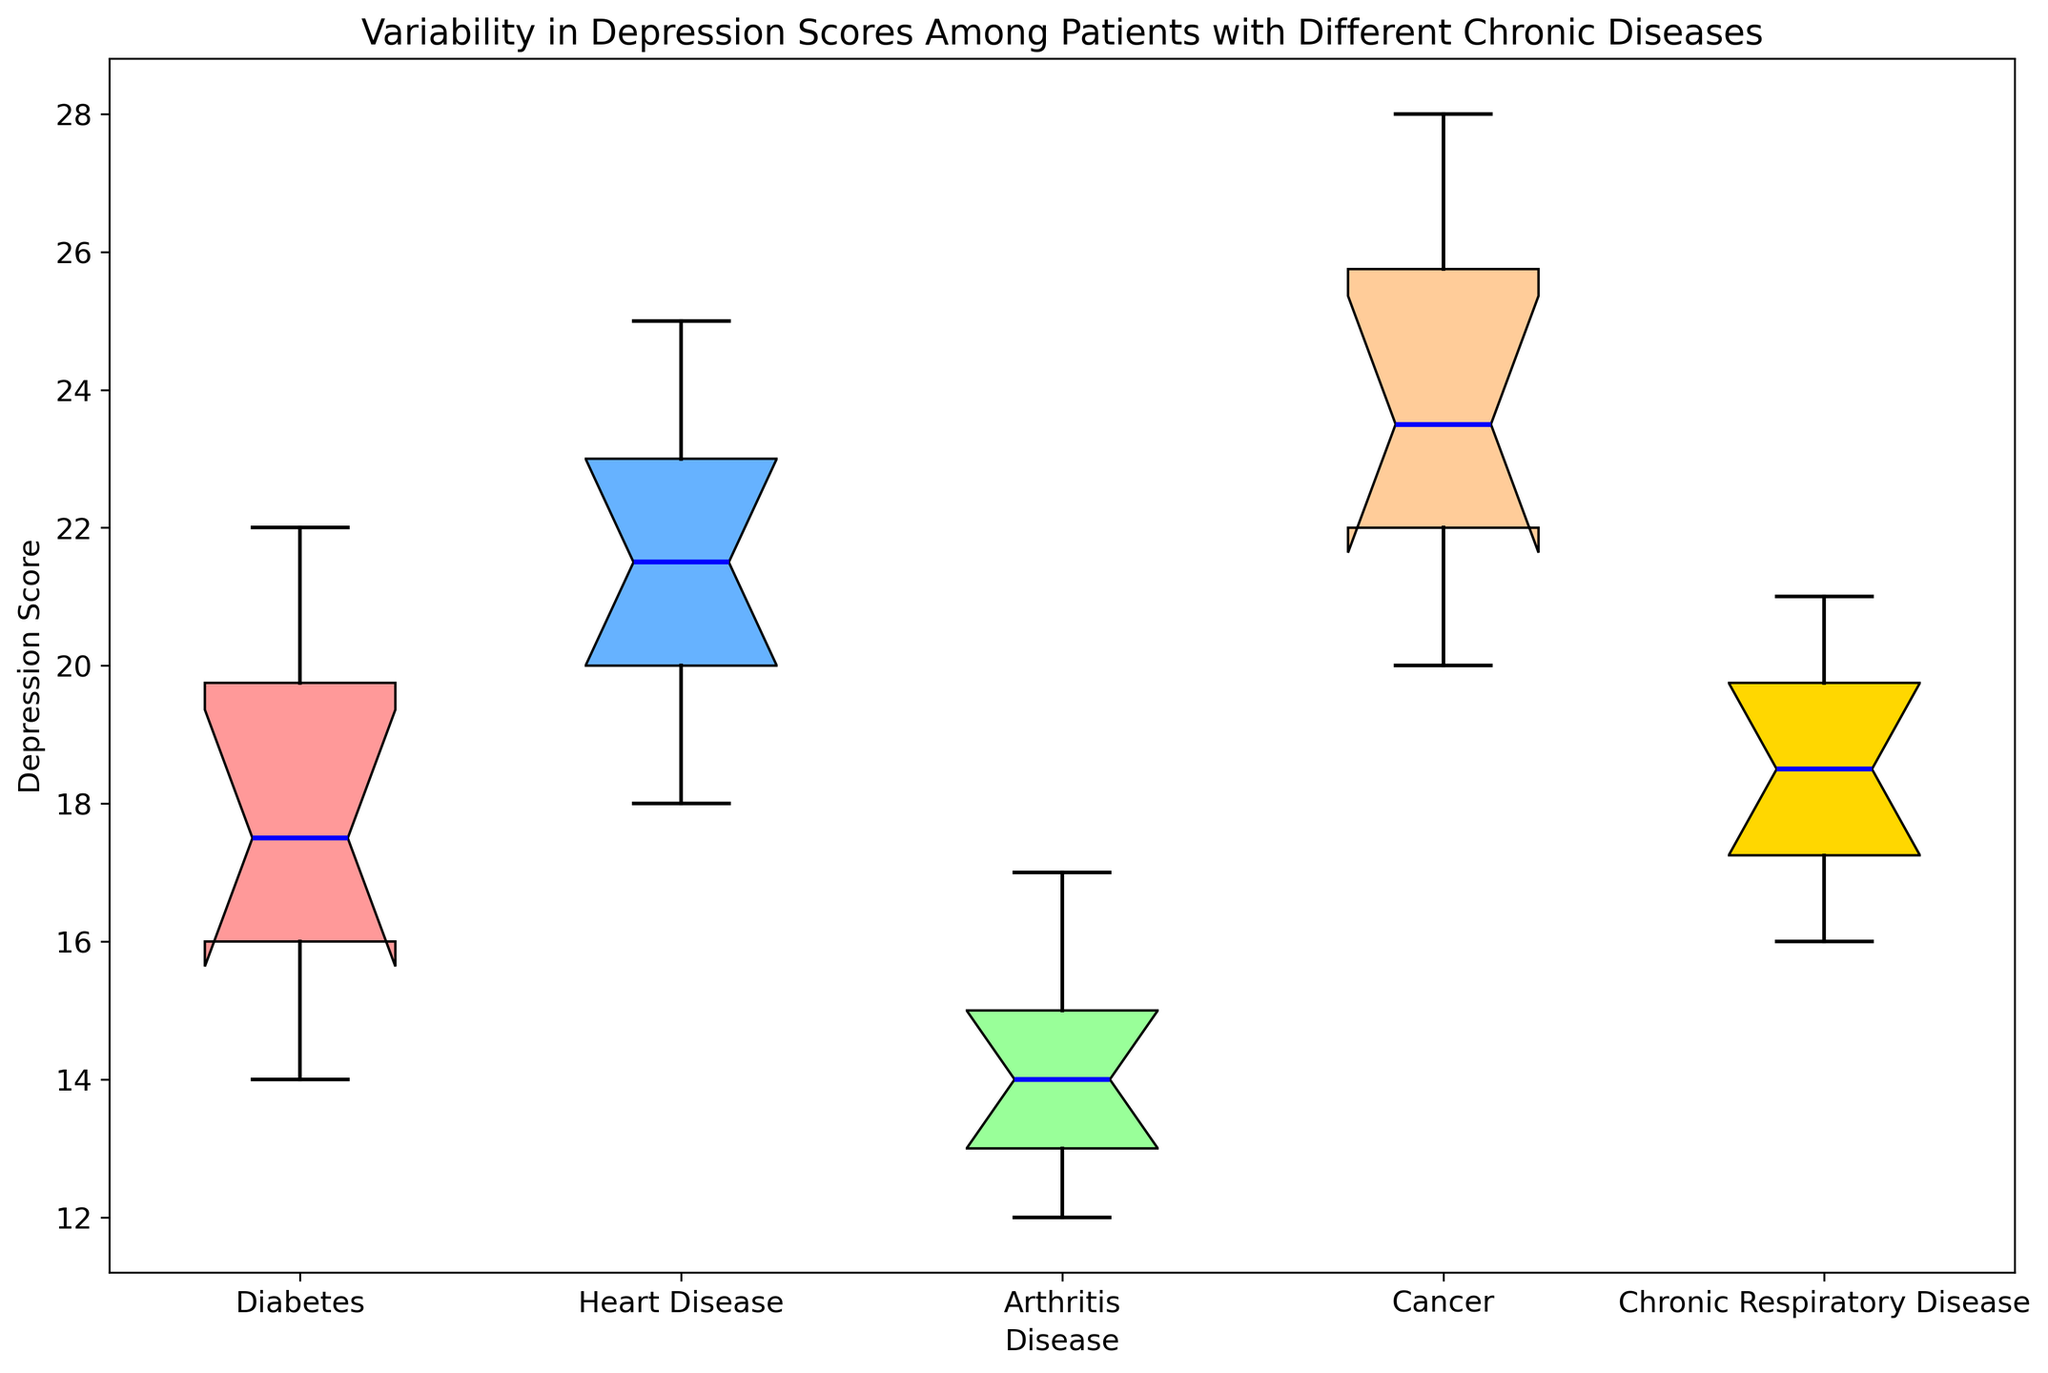Which disease has the highest median depression score? From the box plot, locate the median lines for each disease's box. The highest median line indicates the disease with the highest median depression score.
Answer: Cancer Which disease group shows the smallest variability in depression scores? Variability can be visually assessed by the interquartile range (IQR), represented by the height of the boxes. The smallest IQR indicates the least variability.
Answer: Arthritis What is the range of depression scores for patients with Diabetes? The range is determined by the distance between the smallest and largest observation points (whisker tips) in the Diabetes box plot.
Answer: 14 to 22 Which disease group has the widest interquartile range (IQR) for depression scores? The IQR is represented by the height of the boxes. The box with the greatest height represents the widest IQR.
Answer: Cancer Compare the median depression scores of patients with Chronic Respiratory Disease and Arthritis. Which is higher? Compare the median lines of the two diseases; the higher line represents the higher median depression score.
Answer: Chronic Respiratory Disease Which disease group has the lowest first quartile (Q1) depression score? Identify the bottom edge of the colored box for each disease group; the lowest edge represents the lowest Q1 depression score.
Answer: Arthritis Are there any outliers in the depression scores for Heart Disease? Outliers are indicated by individual points outside the whiskers. Check the Heart Disease box plot for any such points.
Answer: No What is the median depression score for patients with Heart Disease? Locate the median line within the Heart Disease box, this line represents the median depression score.
Answer: 22 Compare the interquartile ranges (IQR) for Cancer and Diabetes. Which one has a larger IQR? Compare the heights of the colored boxes for Cancer and Diabetes. The taller box has the larger IQR.
Answer: Cancer 